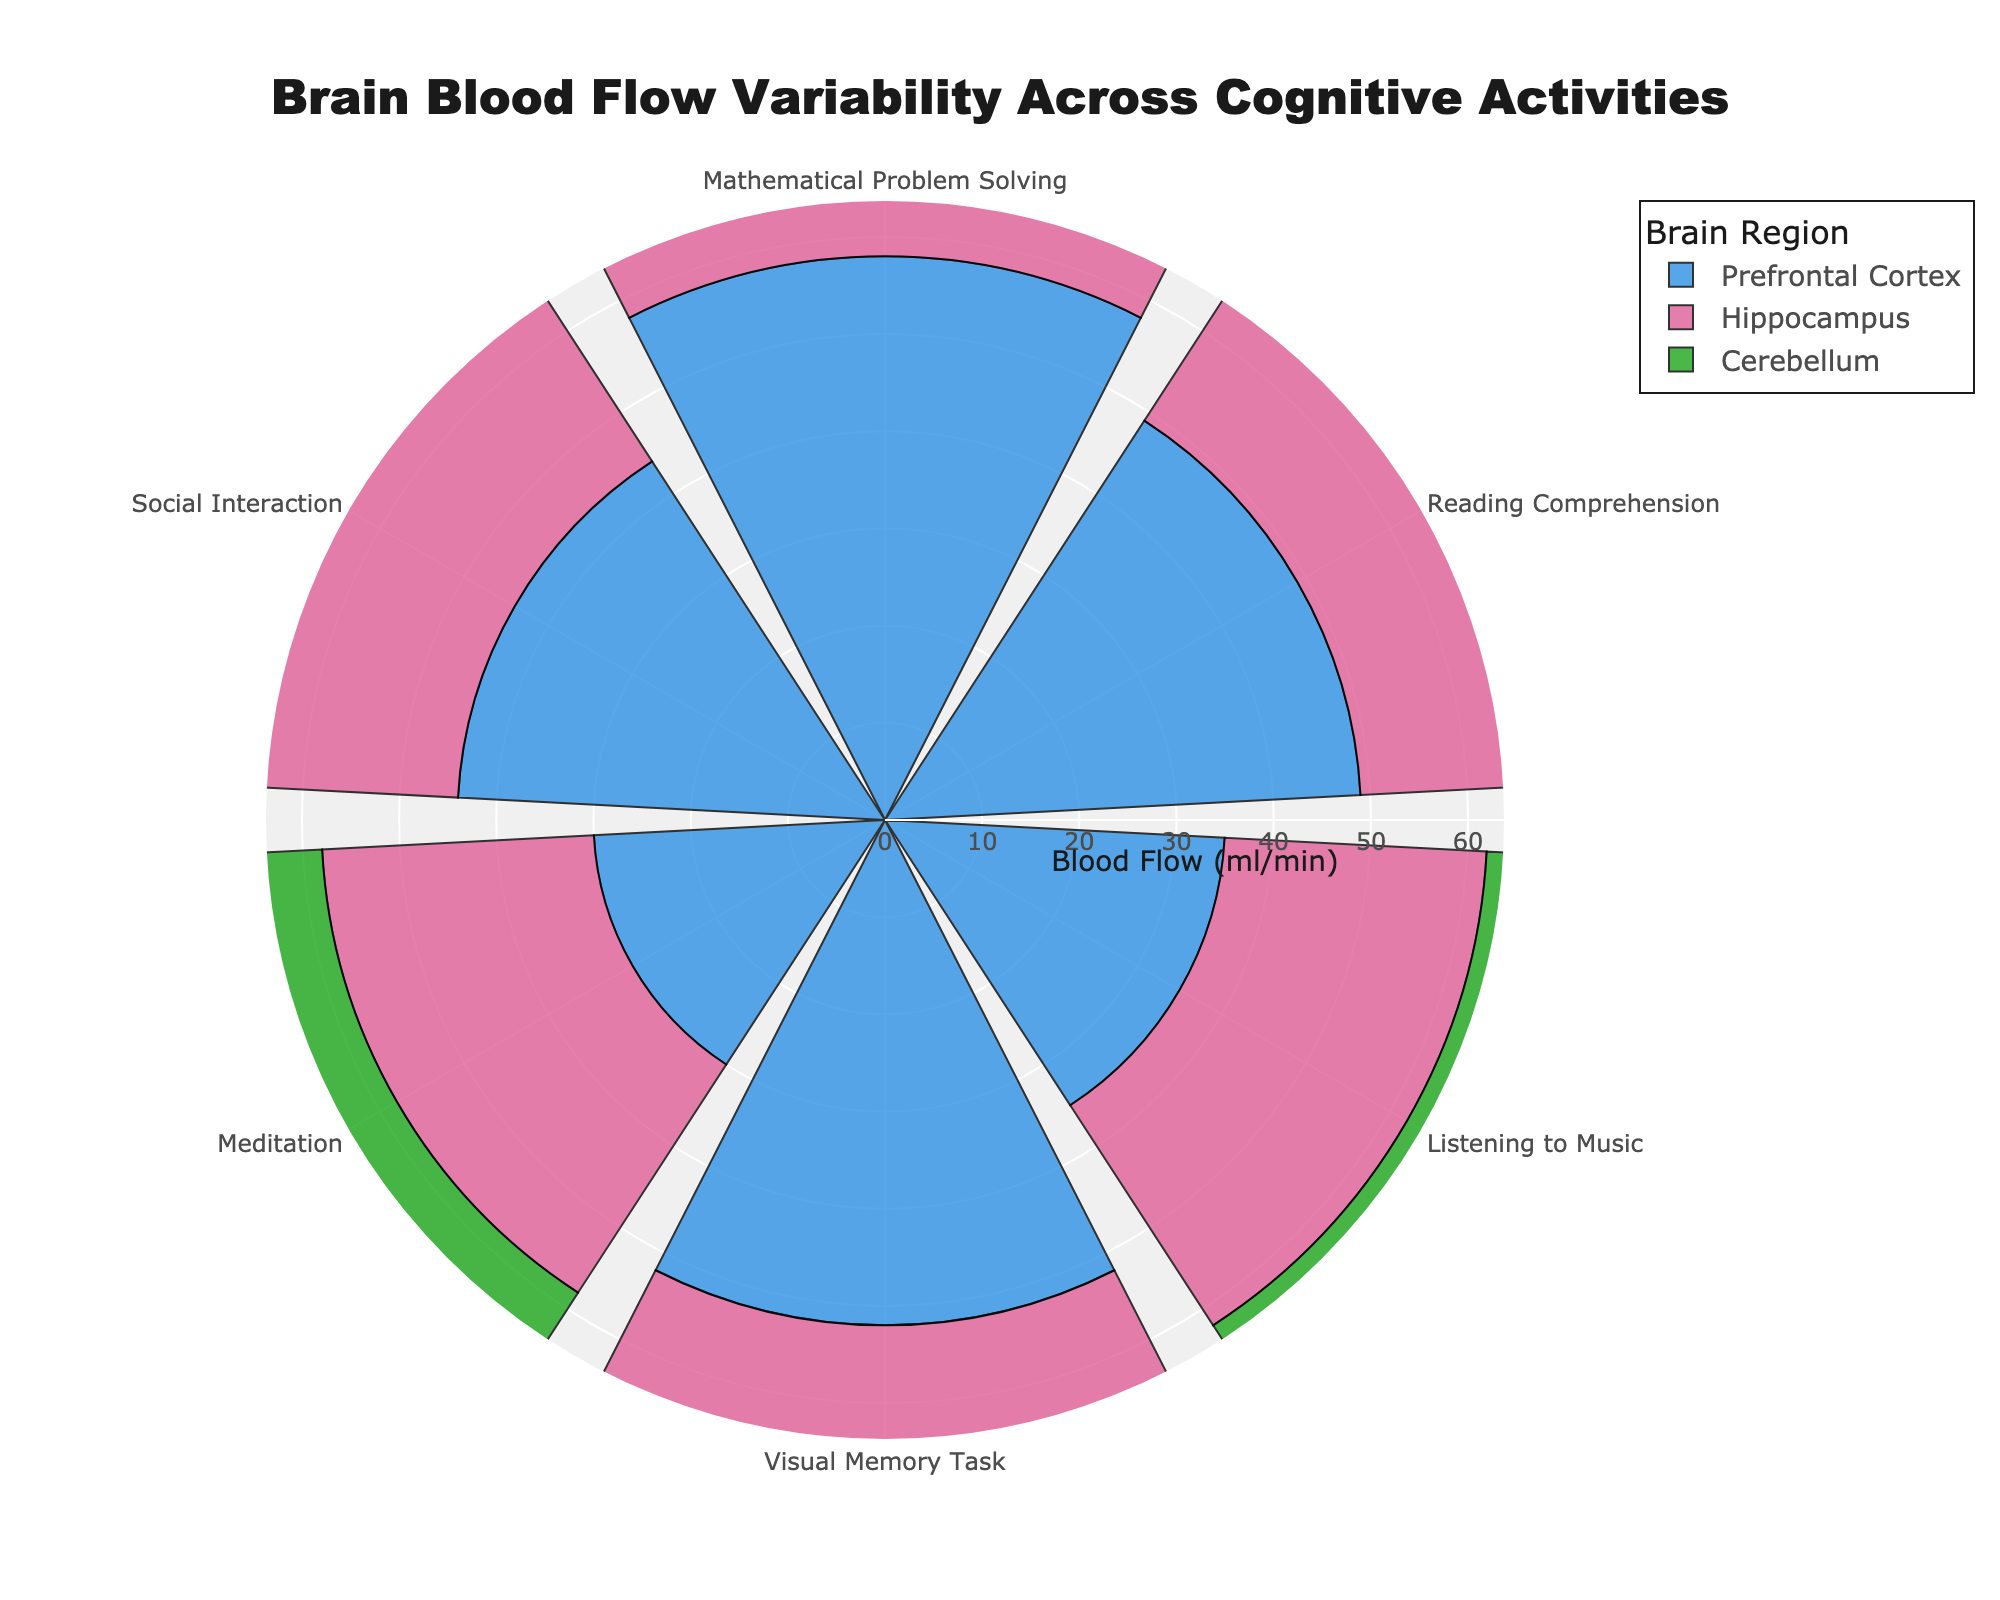Which cognitive activity results in the highest blood flow in the prefrontal cortex? Look at the bars corresponding to the prefrontal cortex for each cognitive activity. The highest bar represents Mathematical Problem Solving with a blood flow of 58 ml/min.
Answer: Mathematical Problem Solving What's the lowest blood flow recorded in the cerebellum across all cognitive activities? Check the bars for the cerebellum in all activities. The lowest value is for Meditation with a blood flow of 26 ml/min.
Answer: 26 ml/min What's the average blood flow in the hippocampus across all activities? Sum all hippocampus blood flow values (45 + 38 + 27 + 47 + 28 + 36 = 221 ml/min) and divide by the number of activities (6). The average is \( \frac{221}{6} \approx 36.83 \).
Answer: 36.83 ml/min Which brain region shows the most variability in blood flow across different activities? Compare the range of blood flow values for each brain region. The prefrontal cortex ranges from 30 (Meditation) to 58 ml/min (Mathematical Problem Solving), showing the largest variability.
Answer: Prefrontal Cortex During Reading Comprehension, which brain region has the highest blood flow? Locate the Reading Comprehension bars and compare the values. The prefrontal cortex has the highest value of 49 ml/min.
Answer: Prefrontal Cortex What's the difference in blood flow between Mathematical Problem Solving and Meditation in the Prefrontal Cortex? Subtract the blood flow of Meditation (30 ml/min) from Mathematical Problem Solving (58 ml/min): \( 58 - 30 = 28 \).
Answer: 28 ml/min Which cognitive activity shows the least blood flow in the prefrontal cortex? Check the bars for the prefrontal cortex. The lowest value is in Meditation with a blood flow of 30 ml/min.
Answer: Meditation How does the blood flow in the hippocampus for Listening to Music compare to that for Social Interaction? Compare the values: 27 ml/min for Listening to Music and 36 ml/min for Social Interaction. Social Interaction has higher blood flow.
Answer: Social Interaction Is there any activity where the blood flow in the cerebellum is higher than in the hippocampus? Compare the cerebellum and hippocampus values for each activity. For Listening to Music, cerebellum (32 ml/min) is higher than hippocampus (27 ml/min).
Answer: Yes What's the range of blood flow values in the prefrontal cortex across all activities? Identify the maximum (58 ml/min for Mathematical Problem Solving) and minimum (30 ml/min for Meditation) values. The range is \( 58 - 30 = 28 \).
Answer: 28 ml/min 